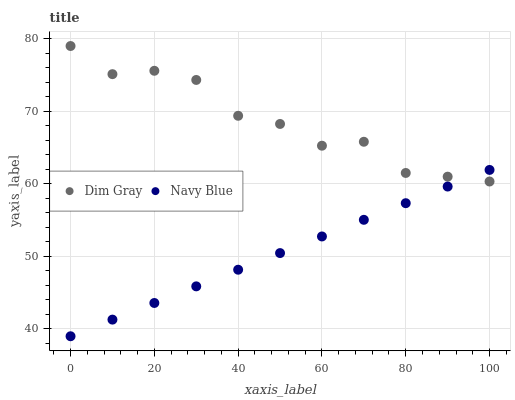Does Navy Blue have the minimum area under the curve?
Answer yes or no. Yes. Does Dim Gray have the maximum area under the curve?
Answer yes or no. Yes. Does Dim Gray have the minimum area under the curve?
Answer yes or no. No. Is Navy Blue the smoothest?
Answer yes or no. Yes. Is Dim Gray the roughest?
Answer yes or no. Yes. Is Dim Gray the smoothest?
Answer yes or no. No. Does Navy Blue have the lowest value?
Answer yes or no. Yes. Does Dim Gray have the lowest value?
Answer yes or no. No. Does Dim Gray have the highest value?
Answer yes or no. Yes. Does Navy Blue intersect Dim Gray?
Answer yes or no. Yes. Is Navy Blue less than Dim Gray?
Answer yes or no. No. Is Navy Blue greater than Dim Gray?
Answer yes or no. No. 